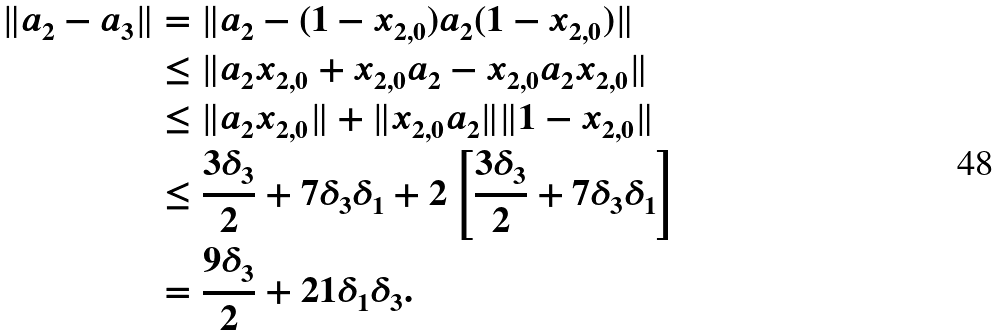Convert formula to latex. <formula><loc_0><loc_0><loc_500><loc_500>\| a _ { 2 } - a _ { 3 } \| & = \| a _ { 2 } - ( 1 - x _ { 2 , 0 } ) a _ { 2 } ( 1 - x _ { 2 , 0 } ) \| \\ & \leq \| a _ { 2 } x _ { 2 , 0 } + x _ { 2 , 0 } a _ { 2 } - x _ { 2 , 0 } a _ { 2 } x _ { 2 , 0 } \| \\ & \leq \| a _ { 2 } x _ { 2 , 0 } \| + \| x _ { 2 , 0 } a _ { 2 } \| \| 1 - x _ { 2 , 0 } \| \\ & \leq \frac { 3 \delta _ { 3 } } { 2 } + 7 \delta _ { 3 } \delta _ { 1 } + 2 \left [ \frac { 3 \delta _ { 3 } } { 2 } + 7 \delta _ { 3 } \delta _ { 1 } \right ] \\ & = \frac { 9 \delta _ { 3 } } { 2 } + 2 1 \delta _ { 1 } \delta _ { 3 } .</formula> 